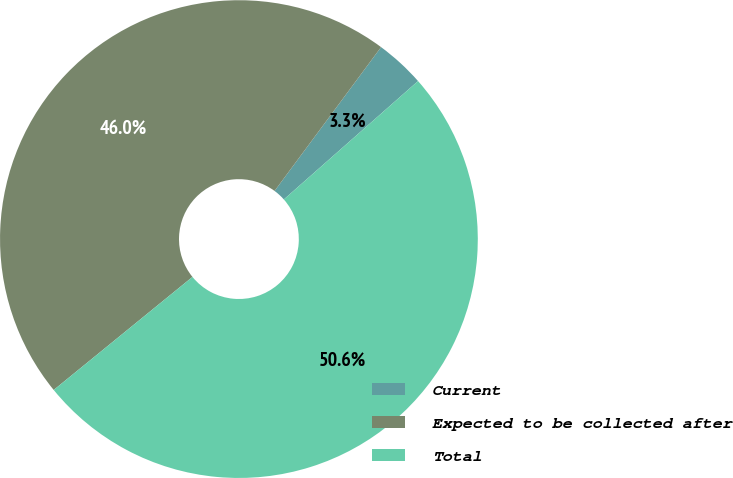Convert chart to OTSL. <chart><loc_0><loc_0><loc_500><loc_500><pie_chart><fcel>Current<fcel>Expected to be collected after<fcel>Total<nl><fcel>3.35%<fcel>46.03%<fcel>50.63%<nl></chart> 